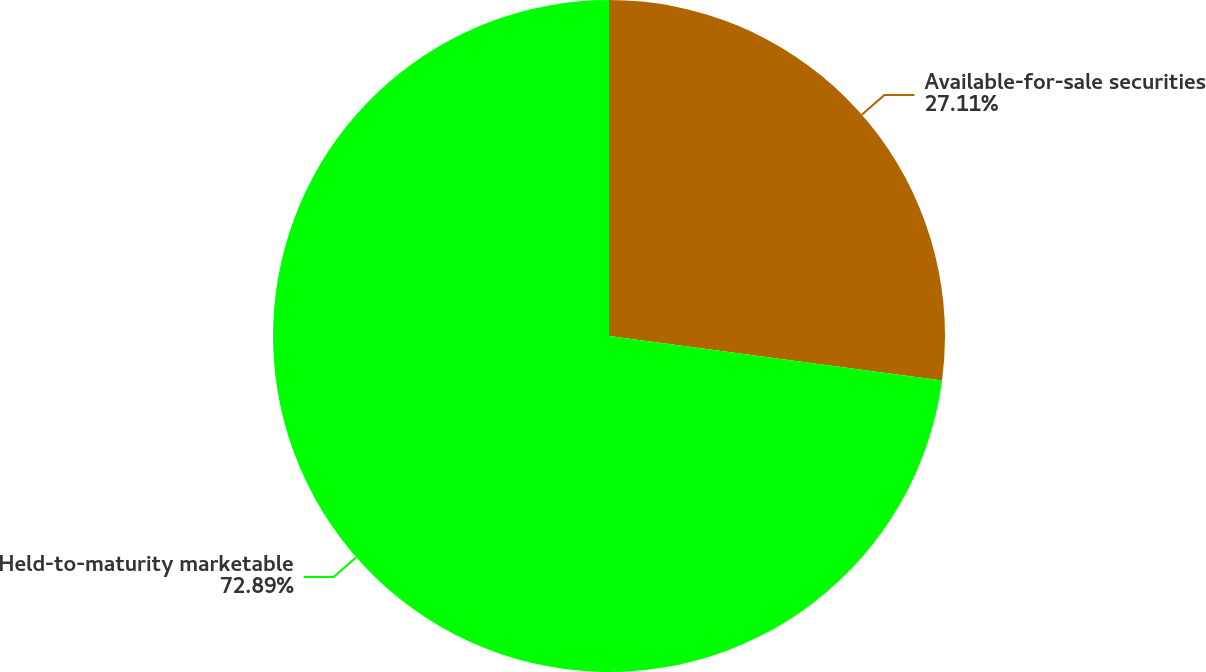<chart> <loc_0><loc_0><loc_500><loc_500><pie_chart><fcel>Available-for-sale securities<fcel>Held-to-maturity marketable<nl><fcel>27.11%<fcel>72.89%<nl></chart> 